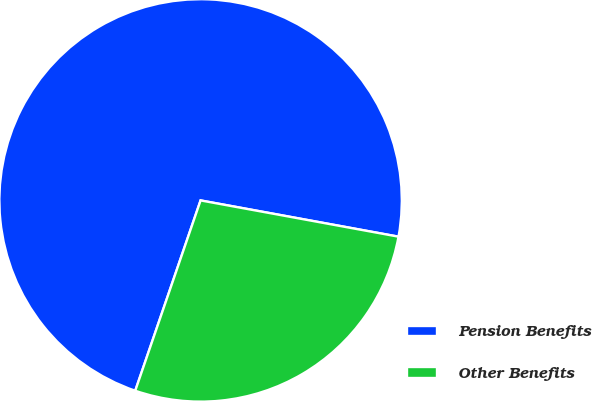Convert chart to OTSL. <chart><loc_0><loc_0><loc_500><loc_500><pie_chart><fcel>Pension Benefits<fcel>Other Benefits<nl><fcel>72.62%<fcel>27.38%<nl></chart> 